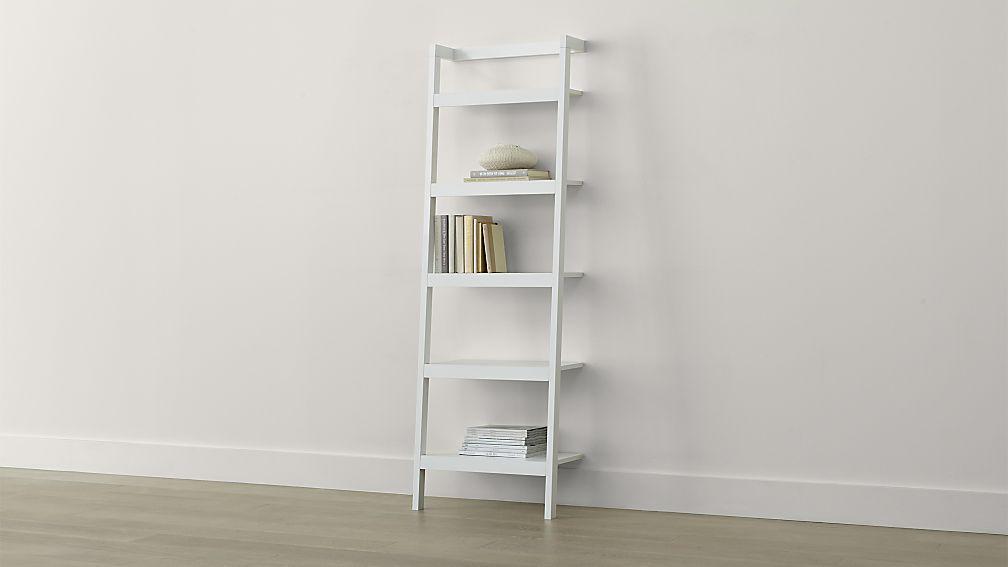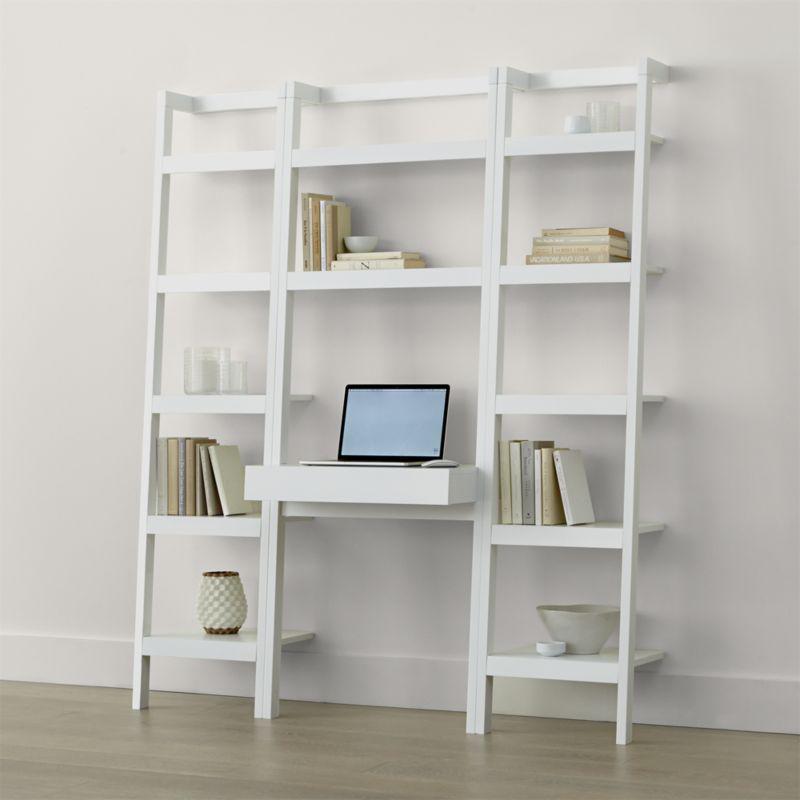The first image is the image on the left, the second image is the image on the right. Evaluate the accuracy of this statement regarding the images: "In one image, a bookshelf has three vertical shelf sections with a computer placed in the center unit.". Is it true? Answer yes or no. Yes. The first image is the image on the left, the second image is the image on the right. For the images shown, is this caption "There us a white bookshelf with a laptop on it ,  a stack of books with a bowl on top of another stack of books are on the shelf above the laptop" true? Answer yes or no. Yes. 